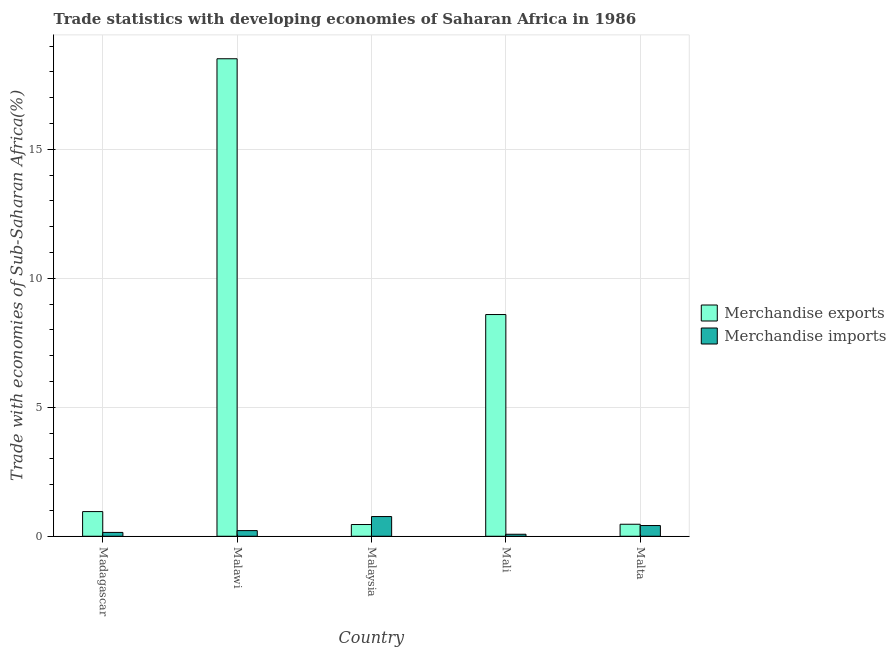How many different coloured bars are there?
Offer a terse response. 2. How many groups of bars are there?
Your answer should be very brief. 5. Are the number of bars per tick equal to the number of legend labels?
Your response must be concise. Yes. Are the number of bars on each tick of the X-axis equal?
Offer a terse response. Yes. How many bars are there on the 3rd tick from the left?
Your answer should be very brief. 2. What is the label of the 3rd group of bars from the left?
Make the answer very short. Malaysia. What is the merchandise exports in Malta?
Give a very brief answer. 0.47. Across all countries, what is the maximum merchandise imports?
Make the answer very short. 0.76. Across all countries, what is the minimum merchandise exports?
Make the answer very short. 0.45. In which country was the merchandise exports maximum?
Provide a succinct answer. Malawi. In which country was the merchandise imports minimum?
Offer a very short reply. Mali. What is the total merchandise imports in the graph?
Make the answer very short. 1.62. What is the difference between the merchandise imports in Madagascar and that in Malta?
Give a very brief answer. -0.27. What is the difference between the merchandise exports in Madagascar and the merchandise imports in Malawi?
Offer a very short reply. 0.74. What is the average merchandise exports per country?
Make the answer very short. 5.8. What is the difference between the merchandise exports and merchandise imports in Malawi?
Offer a terse response. 18.29. What is the ratio of the merchandise imports in Malaysia to that in Malta?
Your response must be concise. 1.84. Is the merchandise exports in Malawi less than that in Malaysia?
Make the answer very short. No. What is the difference between the highest and the second highest merchandise exports?
Offer a terse response. 9.91. What is the difference between the highest and the lowest merchandise exports?
Your answer should be compact. 18.05. Is the sum of the merchandise exports in Madagascar and Malawi greater than the maximum merchandise imports across all countries?
Offer a very short reply. Yes. What does the 1st bar from the right in Malawi represents?
Your answer should be very brief. Merchandise imports. How many bars are there?
Provide a succinct answer. 10. Are all the bars in the graph horizontal?
Your response must be concise. No. How many countries are there in the graph?
Your answer should be compact. 5. What is the difference between two consecutive major ticks on the Y-axis?
Offer a terse response. 5. Does the graph contain any zero values?
Your response must be concise. No. Does the graph contain grids?
Keep it short and to the point. Yes. How many legend labels are there?
Make the answer very short. 2. How are the legend labels stacked?
Offer a terse response. Vertical. What is the title of the graph?
Ensure brevity in your answer.  Trade statistics with developing economies of Saharan Africa in 1986. What is the label or title of the X-axis?
Your answer should be compact. Country. What is the label or title of the Y-axis?
Offer a very short reply. Trade with economies of Sub-Saharan Africa(%). What is the Trade with economies of Sub-Saharan Africa(%) of Merchandise exports in Madagascar?
Your answer should be compact. 0.96. What is the Trade with economies of Sub-Saharan Africa(%) of Merchandise imports in Madagascar?
Your answer should be very brief. 0.15. What is the Trade with economies of Sub-Saharan Africa(%) of Merchandise exports in Malawi?
Give a very brief answer. 18.51. What is the Trade with economies of Sub-Saharan Africa(%) of Merchandise imports in Malawi?
Keep it short and to the point. 0.22. What is the Trade with economies of Sub-Saharan Africa(%) of Merchandise exports in Malaysia?
Your answer should be very brief. 0.45. What is the Trade with economies of Sub-Saharan Africa(%) of Merchandise imports in Malaysia?
Provide a short and direct response. 0.76. What is the Trade with economies of Sub-Saharan Africa(%) of Merchandise exports in Mali?
Ensure brevity in your answer.  8.59. What is the Trade with economies of Sub-Saharan Africa(%) in Merchandise imports in Mali?
Your answer should be compact. 0.08. What is the Trade with economies of Sub-Saharan Africa(%) of Merchandise exports in Malta?
Your answer should be very brief. 0.47. What is the Trade with economies of Sub-Saharan Africa(%) of Merchandise imports in Malta?
Ensure brevity in your answer.  0.42. Across all countries, what is the maximum Trade with economies of Sub-Saharan Africa(%) of Merchandise exports?
Give a very brief answer. 18.51. Across all countries, what is the maximum Trade with economies of Sub-Saharan Africa(%) of Merchandise imports?
Provide a succinct answer. 0.76. Across all countries, what is the minimum Trade with economies of Sub-Saharan Africa(%) in Merchandise exports?
Provide a short and direct response. 0.45. Across all countries, what is the minimum Trade with economies of Sub-Saharan Africa(%) in Merchandise imports?
Provide a short and direct response. 0.08. What is the total Trade with economies of Sub-Saharan Africa(%) of Merchandise exports in the graph?
Your answer should be very brief. 28.98. What is the total Trade with economies of Sub-Saharan Africa(%) of Merchandise imports in the graph?
Keep it short and to the point. 1.62. What is the difference between the Trade with economies of Sub-Saharan Africa(%) in Merchandise exports in Madagascar and that in Malawi?
Provide a short and direct response. -17.55. What is the difference between the Trade with economies of Sub-Saharan Africa(%) of Merchandise imports in Madagascar and that in Malawi?
Your response must be concise. -0.07. What is the difference between the Trade with economies of Sub-Saharan Africa(%) in Merchandise exports in Madagascar and that in Malaysia?
Your answer should be very brief. 0.5. What is the difference between the Trade with economies of Sub-Saharan Africa(%) of Merchandise imports in Madagascar and that in Malaysia?
Give a very brief answer. -0.62. What is the difference between the Trade with economies of Sub-Saharan Africa(%) of Merchandise exports in Madagascar and that in Mali?
Your answer should be very brief. -7.64. What is the difference between the Trade with economies of Sub-Saharan Africa(%) in Merchandise imports in Madagascar and that in Mali?
Ensure brevity in your answer.  0.07. What is the difference between the Trade with economies of Sub-Saharan Africa(%) in Merchandise exports in Madagascar and that in Malta?
Your answer should be compact. 0.49. What is the difference between the Trade with economies of Sub-Saharan Africa(%) in Merchandise imports in Madagascar and that in Malta?
Your response must be concise. -0.27. What is the difference between the Trade with economies of Sub-Saharan Africa(%) of Merchandise exports in Malawi and that in Malaysia?
Offer a terse response. 18.05. What is the difference between the Trade with economies of Sub-Saharan Africa(%) in Merchandise imports in Malawi and that in Malaysia?
Ensure brevity in your answer.  -0.54. What is the difference between the Trade with economies of Sub-Saharan Africa(%) in Merchandise exports in Malawi and that in Mali?
Provide a short and direct response. 9.91. What is the difference between the Trade with economies of Sub-Saharan Africa(%) of Merchandise imports in Malawi and that in Mali?
Your answer should be compact. 0.14. What is the difference between the Trade with economies of Sub-Saharan Africa(%) in Merchandise exports in Malawi and that in Malta?
Your response must be concise. 18.04. What is the difference between the Trade with economies of Sub-Saharan Africa(%) of Merchandise imports in Malawi and that in Malta?
Offer a terse response. -0.2. What is the difference between the Trade with economies of Sub-Saharan Africa(%) of Merchandise exports in Malaysia and that in Mali?
Give a very brief answer. -8.14. What is the difference between the Trade with economies of Sub-Saharan Africa(%) in Merchandise imports in Malaysia and that in Mali?
Offer a very short reply. 0.69. What is the difference between the Trade with economies of Sub-Saharan Africa(%) in Merchandise exports in Malaysia and that in Malta?
Provide a short and direct response. -0.01. What is the difference between the Trade with economies of Sub-Saharan Africa(%) in Merchandise imports in Malaysia and that in Malta?
Your answer should be compact. 0.35. What is the difference between the Trade with economies of Sub-Saharan Africa(%) of Merchandise exports in Mali and that in Malta?
Give a very brief answer. 8.13. What is the difference between the Trade with economies of Sub-Saharan Africa(%) in Merchandise imports in Mali and that in Malta?
Your answer should be compact. -0.34. What is the difference between the Trade with economies of Sub-Saharan Africa(%) in Merchandise exports in Madagascar and the Trade with economies of Sub-Saharan Africa(%) in Merchandise imports in Malawi?
Provide a short and direct response. 0.74. What is the difference between the Trade with economies of Sub-Saharan Africa(%) of Merchandise exports in Madagascar and the Trade with economies of Sub-Saharan Africa(%) of Merchandise imports in Malaysia?
Your answer should be very brief. 0.19. What is the difference between the Trade with economies of Sub-Saharan Africa(%) in Merchandise exports in Madagascar and the Trade with economies of Sub-Saharan Africa(%) in Merchandise imports in Mali?
Ensure brevity in your answer.  0.88. What is the difference between the Trade with economies of Sub-Saharan Africa(%) of Merchandise exports in Madagascar and the Trade with economies of Sub-Saharan Africa(%) of Merchandise imports in Malta?
Your answer should be compact. 0.54. What is the difference between the Trade with economies of Sub-Saharan Africa(%) in Merchandise exports in Malawi and the Trade with economies of Sub-Saharan Africa(%) in Merchandise imports in Malaysia?
Offer a very short reply. 17.74. What is the difference between the Trade with economies of Sub-Saharan Africa(%) of Merchandise exports in Malawi and the Trade with economies of Sub-Saharan Africa(%) of Merchandise imports in Mali?
Keep it short and to the point. 18.43. What is the difference between the Trade with economies of Sub-Saharan Africa(%) of Merchandise exports in Malawi and the Trade with economies of Sub-Saharan Africa(%) of Merchandise imports in Malta?
Your answer should be compact. 18.09. What is the difference between the Trade with economies of Sub-Saharan Africa(%) in Merchandise exports in Malaysia and the Trade with economies of Sub-Saharan Africa(%) in Merchandise imports in Mali?
Your response must be concise. 0.38. What is the difference between the Trade with economies of Sub-Saharan Africa(%) in Merchandise exports in Malaysia and the Trade with economies of Sub-Saharan Africa(%) in Merchandise imports in Malta?
Keep it short and to the point. 0.04. What is the difference between the Trade with economies of Sub-Saharan Africa(%) in Merchandise exports in Mali and the Trade with economies of Sub-Saharan Africa(%) in Merchandise imports in Malta?
Your answer should be very brief. 8.18. What is the average Trade with economies of Sub-Saharan Africa(%) in Merchandise exports per country?
Make the answer very short. 5.8. What is the average Trade with economies of Sub-Saharan Africa(%) of Merchandise imports per country?
Make the answer very short. 0.32. What is the difference between the Trade with economies of Sub-Saharan Africa(%) in Merchandise exports and Trade with economies of Sub-Saharan Africa(%) in Merchandise imports in Madagascar?
Offer a very short reply. 0.81. What is the difference between the Trade with economies of Sub-Saharan Africa(%) of Merchandise exports and Trade with economies of Sub-Saharan Africa(%) of Merchandise imports in Malawi?
Provide a short and direct response. 18.29. What is the difference between the Trade with economies of Sub-Saharan Africa(%) of Merchandise exports and Trade with economies of Sub-Saharan Africa(%) of Merchandise imports in Malaysia?
Offer a very short reply. -0.31. What is the difference between the Trade with economies of Sub-Saharan Africa(%) in Merchandise exports and Trade with economies of Sub-Saharan Africa(%) in Merchandise imports in Mali?
Offer a terse response. 8.52. What is the difference between the Trade with economies of Sub-Saharan Africa(%) in Merchandise exports and Trade with economies of Sub-Saharan Africa(%) in Merchandise imports in Malta?
Keep it short and to the point. 0.05. What is the ratio of the Trade with economies of Sub-Saharan Africa(%) of Merchandise exports in Madagascar to that in Malawi?
Make the answer very short. 0.05. What is the ratio of the Trade with economies of Sub-Saharan Africa(%) of Merchandise imports in Madagascar to that in Malawi?
Provide a short and direct response. 0.68. What is the ratio of the Trade with economies of Sub-Saharan Africa(%) in Merchandise exports in Madagascar to that in Malaysia?
Ensure brevity in your answer.  2.1. What is the ratio of the Trade with economies of Sub-Saharan Africa(%) in Merchandise imports in Madagascar to that in Malaysia?
Provide a succinct answer. 0.19. What is the ratio of the Trade with economies of Sub-Saharan Africa(%) in Merchandise exports in Madagascar to that in Mali?
Make the answer very short. 0.11. What is the ratio of the Trade with economies of Sub-Saharan Africa(%) in Merchandise imports in Madagascar to that in Mali?
Your answer should be compact. 1.93. What is the ratio of the Trade with economies of Sub-Saharan Africa(%) in Merchandise exports in Madagascar to that in Malta?
Provide a succinct answer. 2.05. What is the ratio of the Trade with economies of Sub-Saharan Africa(%) of Merchandise imports in Madagascar to that in Malta?
Provide a succinct answer. 0.36. What is the ratio of the Trade with economies of Sub-Saharan Africa(%) of Merchandise exports in Malawi to that in Malaysia?
Your answer should be compact. 40.71. What is the ratio of the Trade with economies of Sub-Saharan Africa(%) in Merchandise imports in Malawi to that in Malaysia?
Give a very brief answer. 0.29. What is the ratio of the Trade with economies of Sub-Saharan Africa(%) of Merchandise exports in Malawi to that in Mali?
Keep it short and to the point. 2.15. What is the ratio of the Trade with economies of Sub-Saharan Africa(%) of Merchandise imports in Malawi to that in Mali?
Offer a very short reply. 2.85. What is the ratio of the Trade with economies of Sub-Saharan Africa(%) in Merchandise exports in Malawi to that in Malta?
Provide a short and direct response. 39.76. What is the ratio of the Trade with economies of Sub-Saharan Africa(%) in Merchandise imports in Malawi to that in Malta?
Provide a succinct answer. 0.53. What is the ratio of the Trade with economies of Sub-Saharan Africa(%) in Merchandise exports in Malaysia to that in Mali?
Give a very brief answer. 0.05. What is the ratio of the Trade with economies of Sub-Saharan Africa(%) of Merchandise imports in Malaysia to that in Mali?
Keep it short and to the point. 9.92. What is the ratio of the Trade with economies of Sub-Saharan Africa(%) of Merchandise exports in Malaysia to that in Malta?
Offer a terse response. 0.98. What is the ratio of the Trade with economies of Sub-Saharan Africa(%) in Merchandise imports in Malaysia to that in Malta?
Your response must be concise. 1.84. What is the ratio of the Trade with economies of Sub-Saharan Africa(%) in Merchandise exports in Mali to that in Malta?
Your answer should be very brief. 18.46. What is the ratio of the Trade with economies of Sub-Saharan Africa(%) in Merchandise imports in Mali to that in Malta?
Make the answer very short. 0.19. What is the difference between the highest and the second highest Trade with economies of Sub-Saharan Africa(%) in Merchandise exports?
Provide a short and direct response. 9.91. What is the difference between the highest and the second highest Trade with economies of Sub-Saharan Africa(%) of Merchandise imports?
Offer a terse response. 0.35. What is the difference between the highest and the lowest Trade with economies of Sub-Saharan Africa(%) in Merchandise exports?
Give a very brief answer. 18.05. What is the difference between the highest and the lowest Trade with economies of Sub-Saharan Africa(%) in Merchandise imports?
Your answer should be very brief. 0.69. 